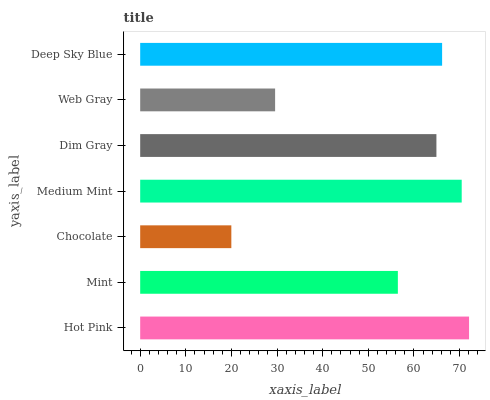Is Chocolate the minimum?
Answer yes or no. Yes. Is Hot Pink the maximum?
Answer yes or no. Yes. Is Mint the minimum?
Answer yes or no. No. Is Mint the maximum?
Answer yes or no. No. Is Hot Pink greater than Mint?
Answer yes or no. Yes. Is Mint less than Hot Pink?
Answer yes or no. Yes. Is Mint greater than Hot Pink?
Answer yes or no. No. Is Hot Pink less than Mint?
Answer yes or no. No. Is Dim Gray the high median?
Answer yes or no. Yes. Is Dim Gray the low median?
Answer yes or no. Yes. Is Medium Mint the high median?
Answer yes or no. No. Is Medium Mint the low median?
Answer yes or no. No. 